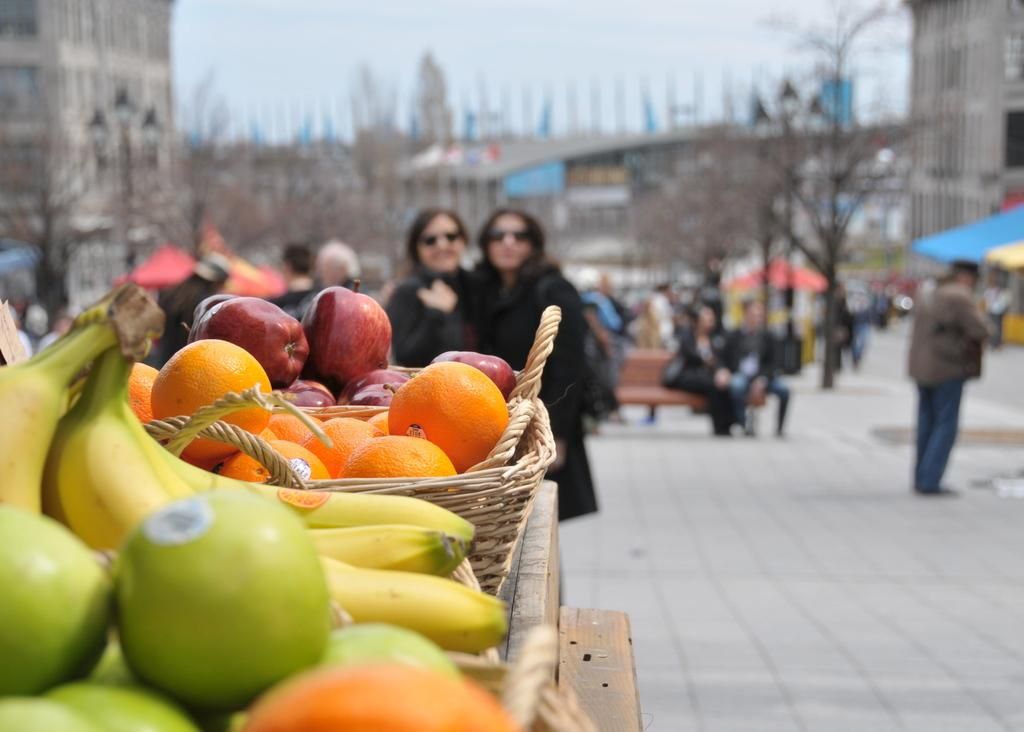What is on the table in the image? There are different fruits on a table in the image. What else can be seen in the image besides the fruits? There are people on a path around the table, and other buildings are visible in the background of the image. What type of loaf is being carried by the person on the path in the image? There is no loaf visible in the image; only fruits, people, and buildings are present. 